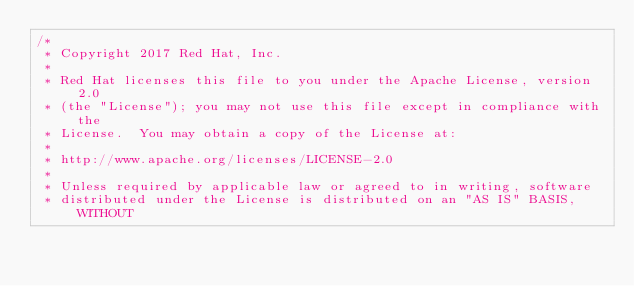<code> <loc_0><loc_0><loc_500><loc_500><_JavaScript_>/*
 * Copyright 2017 Red Hat, Inc.
 *
 * Red Hat licenses this file to you under the Apache License, version 2.0
 * (the "License"); you may not use this file except in compliance with the
 * License.  You may obtain a copy of the License at:
 *
 * http://www.apache.org/licenses/LICENSE-2.0
 *
 * Unless required by applicable law or agreed to in writing, software
 * distributed under the License is distributed on an "AS IS" BASIS, WITHOUT</code> 